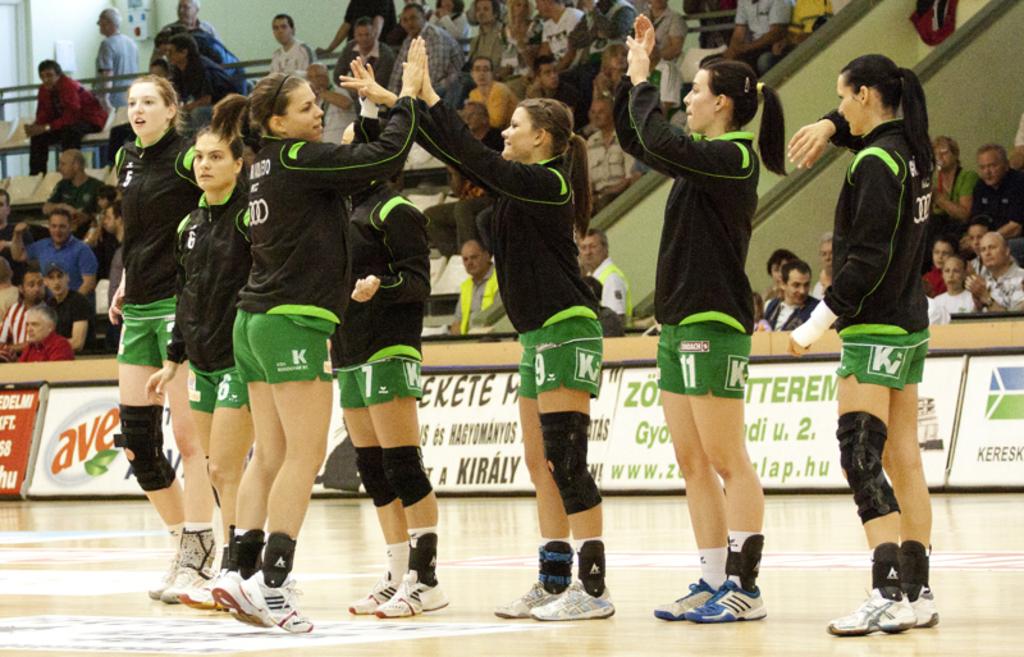What is the players number second from the right?
Give a very brief answer. 11. What is the players number third from the right?
Make the answer very short. 9. 